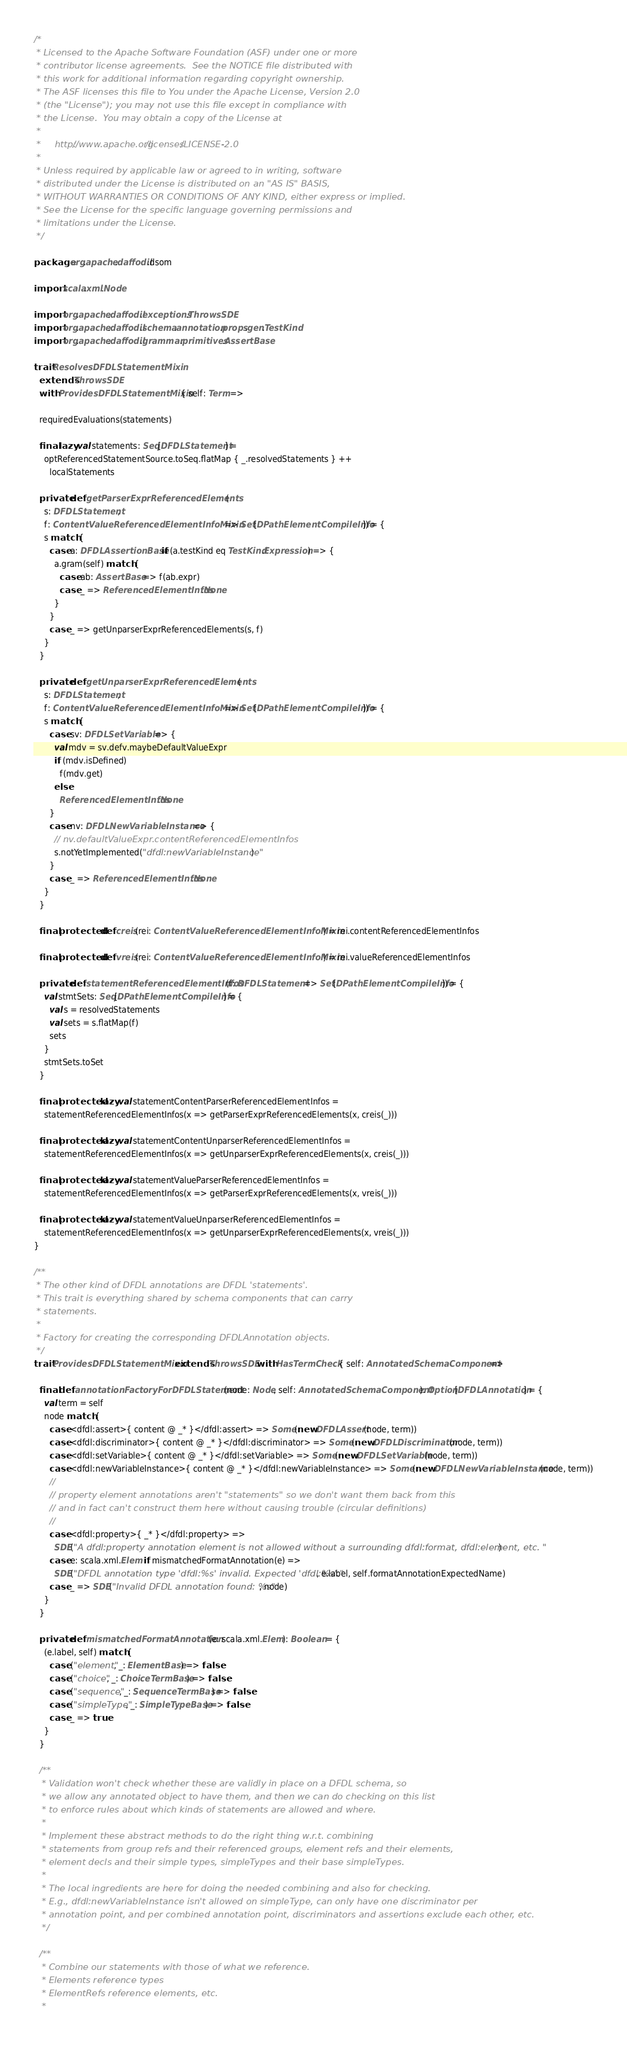Convert code to text. <code><loc_0><loc_0><loc_500><loc_500><_Scala_>/*
 * Licensed to the Apache Software Foundation (ASF) under one or more
 * contributor license agreements.  See the NOTICE file distributed with
 * this work for additional information regarding copyright ownership.
 * The ASF licenses this file to You under the Apache License, Version 2.0
 * (the "License"); you may not use this file except in compliance with
 * the License.  You may obtain a copy of the License at
 *
 *     http://www.apache.org/licenses/LICENSE-2.0
 *
 * Unless required by applicable law or agreed to in writing, software
 * distributed under the License is distributed on an "AS IS" BASIS,
 * WITHOUT WARRANTIES OR CONDITIONS OF ANY KIND, either express or implied.
 * See the License for the specific language governing permissions and
 * limitations under the License.
 */

package org.apache.daffodil.dsom

import scala.xml.Node

import org.apache.daffodil.exceptions.ThrowsSDE
import org.apache.daffodil.schema.annotation.props.gen.TestKind
import org.apache.daffodil.grammar.primitives.AssertBase

trait ResolvesDFDLStatementMixin
  extends ThrowsSDE
  with ProvidesDFDLStatementMixin { self: Term =>

  requiredEvaluations(statements)

  final lazy val statements: Seq[DFDLStatement] =
    optReferencedStatementSource.toSeq.flatMap { _.resolvedStatements } ++
      localStatements

  private def getParserExprReferencedElements(
    s: DFDLStatement,
    f: ContentValueReferencedElementInfoMixin => Set[DPathElementCompileInfo]) = {
    s match {
      case a: DFDLAssertionBase if (a.testKind eq TestKind.Expression) => {
        a.gram(self) match {
          case ab: AssertBase => f(ab.expr)
          case _ => ReferencedElementInfos.None
        }
      }
      case _ => getUnparserExprReferencedElements(s, f)
    }
  }

  private def getUnparserExprReferencedElements(
    s: DFDLStatement,
    f: ContentValueReferencedElementInfoMixin => Set[DPathElementCompileInfo]) = {
    s match {
      case sv: DFDLSetVariable => {
        val mdv = sv.defv.maybeDefaultValueExpr
        if (mdv.isDefined)
          f(mdv.get)
        else
          ReferencedElementInfos.None
      }
      case nv: DFDLNewVariableInstance => {
        // nv.defaultValueExpr.contentReferencedElementInfos
        s.notYetImplemented("dfdl:newVariableInstance")
      }
      case _ => ReferencedElementInfos.None
    }
  }

  final protected def creis(rei: ContentValueReferencedElementInfoMixin) = rei.contentReferencedElementInfos

  final protected def vreis(rei: ContentValueReferencedElementInfoMixin) = rei.valueReferencedElementInfos

  private def statementReferencedElementInfos(f: DFDLStatement => Set[DPathElementCompileInfo]) = {
    val stmtSets: Seq[DPathElementCompileInfo] = {
      val s = resolvedStatements
      val sets = s.flatMap(f)
      sets
    }
    stmtSets.toSet
  }

  final protected lazy val statementContentParserReferencedElementInfos =
    statementReferencedElementInfos(x => getParserExprReferencedElements(x, creis(_)))

  final protected lazy val statementContentUnparserReferencedElementInfos =
    statementReferencedElementInfos(x => getUnparserExprReferencedElements(x, creis(_)))

  final protected lazy val statementValueParserReferencedElementInfos =
    statementReferencedElementInfos(x => getParserExprReferencedElements(x, vreis(_)))

  final protected lazy val statementValueUnparserReferencedElementInfos =
    statementReferencedElementInfos(x => getUnparserExprReferencedElements(x, vreis(_)))
}

/**
 * The other kind of DFDL annotations are DFDL 'statements'.
 * This trait is everything shared by schema components that can carry
 * statements.
 *
 * Factory for creating the corresponding DFDLAnnotation objects.
 */
trait ProvidesDFDLStatementMixin extends ThrowsSDE with HasTermCheck { self: AnnotatedSchemaComponent =>

  final def annotationFactoryForDFDLStatement(node: Node, self: AnnotatedSchemaComponent): Option[DFDLAnnotation] = {
    val term = self
    node match {
      case <dfdl:assert>{ content @ _* }</dfdl:assert> => Some(new DFDLAssert(node, term))
      case <dfdl:discriminator>{ content @ _* }</dfdl:discriminator> => Some(new DFDLDiscriminator(node, term))
      case <dfdl:setVariable>{ content @ _* }</dfdl:setVariable> => Some(new DFDLSetVariable(node, term))
      case <dfdl:newVariableInstance>{ content @ _* }</dfdl:newVariableInstance> => Some(new DFDLNewVariableInstance(node, term))
      //
      // property element annotations aren't "statements" so we don't want them back from this
      // and in fact can't construct them here without causing trouble (circular definitions)
      //
      case <dfdl:property>{ _* }</dfdl:property> =>
        SDE("A dfdl:property annotation element is not allowed without a surrounding dfdl:format, dfdl:element, etc. ")
      case e: scala.xml.Elem if mismatchedFormatAnnotation(e) =>
        SDE("DFDL annotation type 'dfdl:%s' invalid. Expected 'dfdl:%s'.", e.label, self.formatAnnotationExpectedName)
      case _ => SDE("Invalid DFDL annotation found: %s", node)
    }
  }

  private def mismatchedFormatAnnotation(e: scala.xml.Elem): Boolean = {
    (e.label, self) match {
      case ("element", _: ElementBase) => false
      case ("choice", _: ChoiceTermBase) => false
      case ("sequence", _: SequenceTermBase) => false
      case ("simpleType", _: SimpleTypeBase) => false
      case _ => true
    }
  }

  /**
   * Validation won't check whether these are validly in place on a DFDL schema, so
   * we allow any annotated object to have them, and then we can do checking on this list
   * to enforce rules about which kinds of statements are allowed and where.
   *
   * Implement these abstract methods to do the right thing w.r.t. combining
   * statements from group refs and their referenced groups, element refs and their elements,
   * element decls and their simple types, simpleTypes and their base simpleTypes.
   *
   * The local ingredients are here for doing the needed combining and also for checking.
   * E.g., dfdl:newVariableInstance isn't allowed on simpleType, can only have one discriminator per
   * annotation point, and per combined annotation point, discriminators and assertions exclude each other, etc.
   */

  /**
   * Combine our statements with those of what we reference.
   * Elements reference types
   * ElementRefs reference elements, etc.
   *</code> 